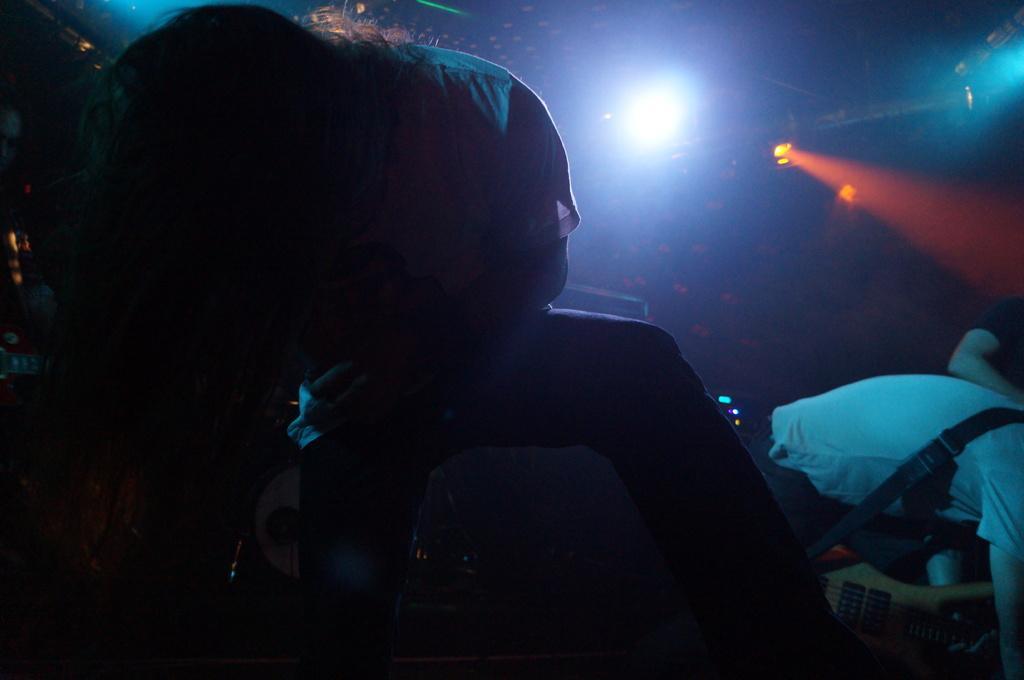Describe this image in one or two sentences. In this picture we can see some people, guitar, lights, some objects and in the background it is dark. 